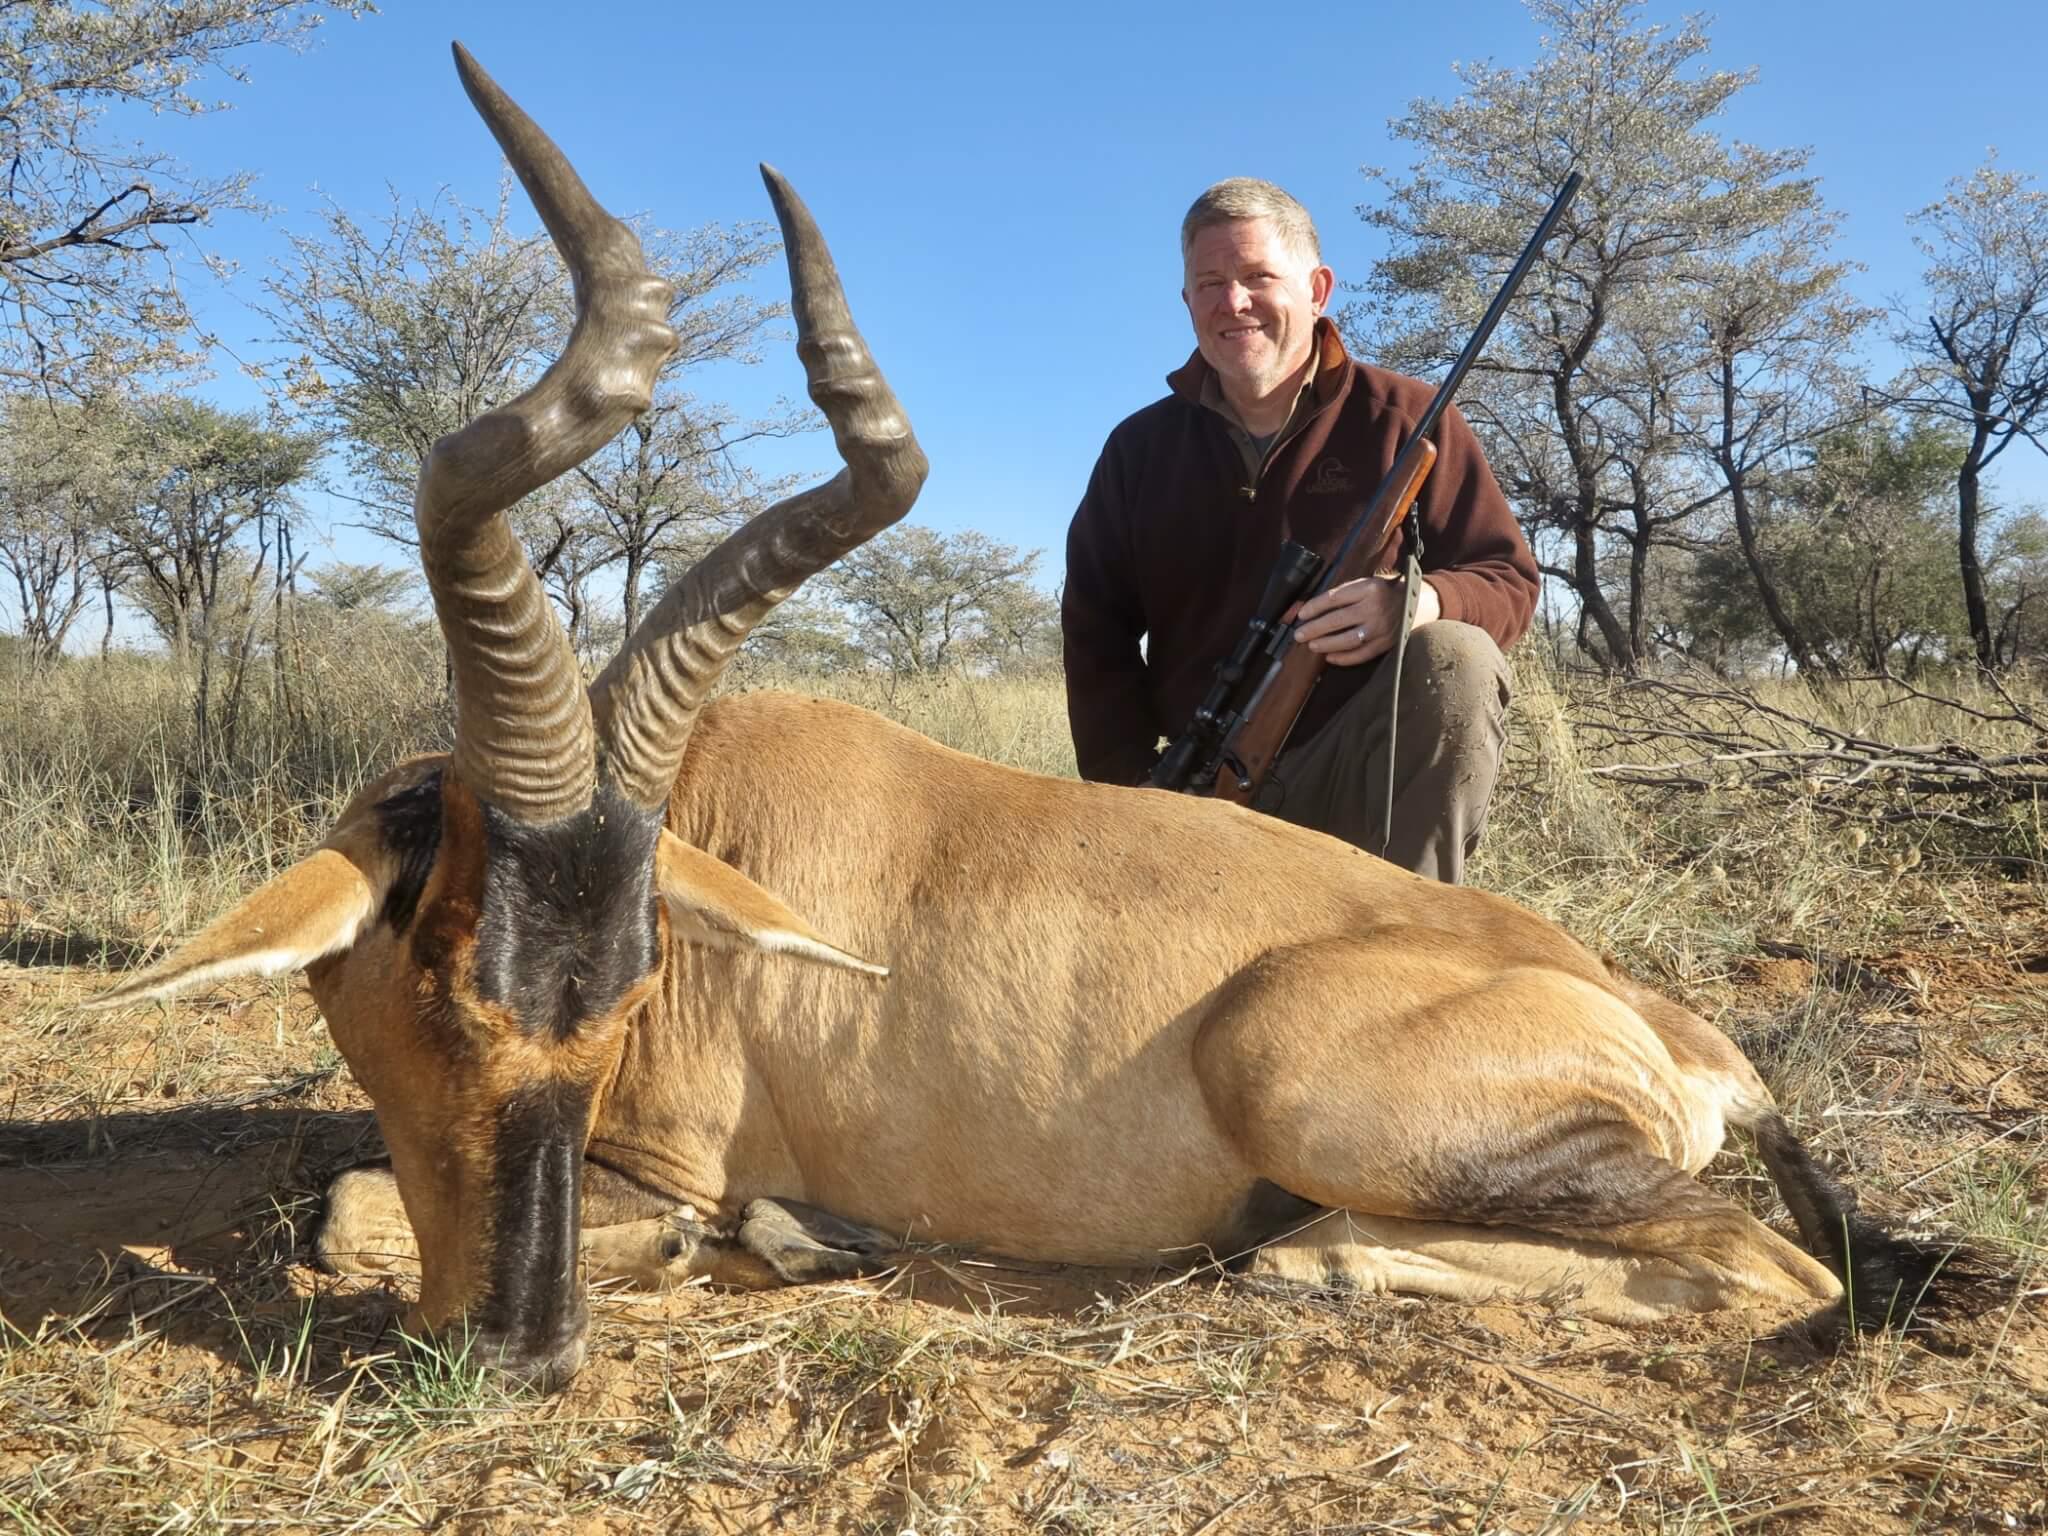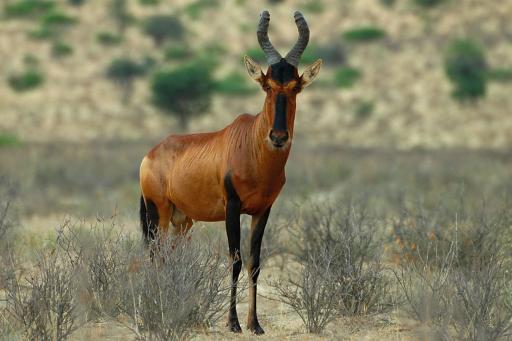The first image is the image on the left, the second image is the image on the right. Assess this claim about the two images: "At least one live ibex is standing in the grass and weeds.". Correct or not? Answer yes or no. Yes. 